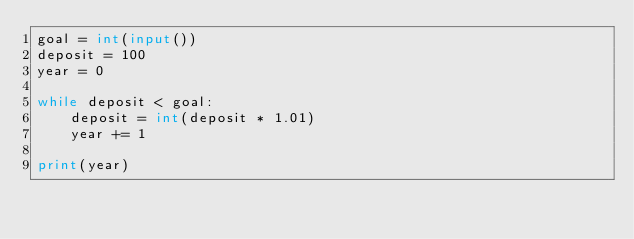Convert code to text. <code><loc_0><loc_0><loc_500><loc_500><_Python_>goal = int(input())
deposit = 100
year = 0

while deposit < goal:
    deposit = int(deposit * 1.01)
    year += 1

print(year)
</code> 